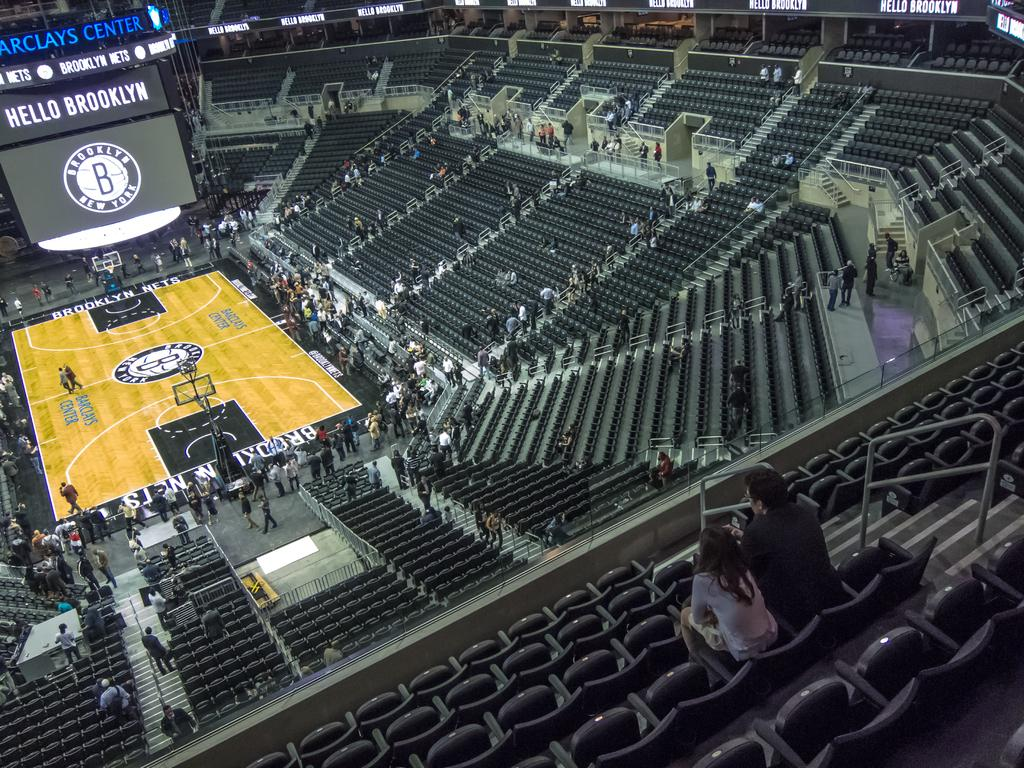<image>
Offer a succinct explanation of the picture presented. A shot from the upper stands of the Barclays center 